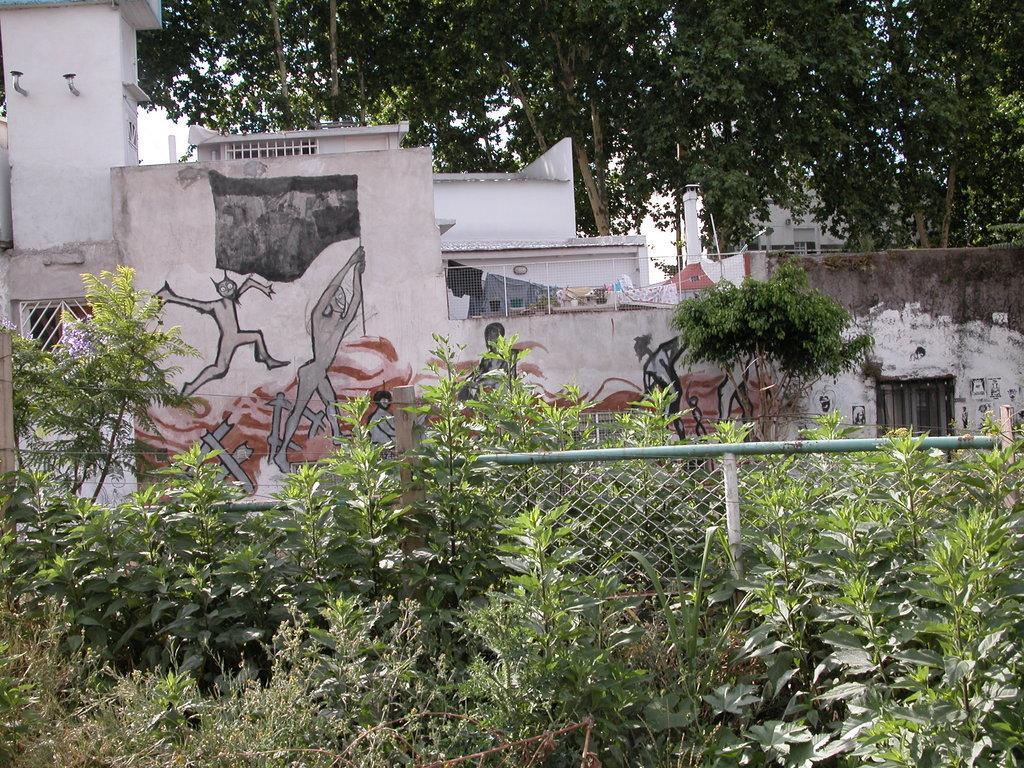Can you describe this image briefly? In this image there are plants, behind the plants there is fencing, in the background there are houses and trees. 